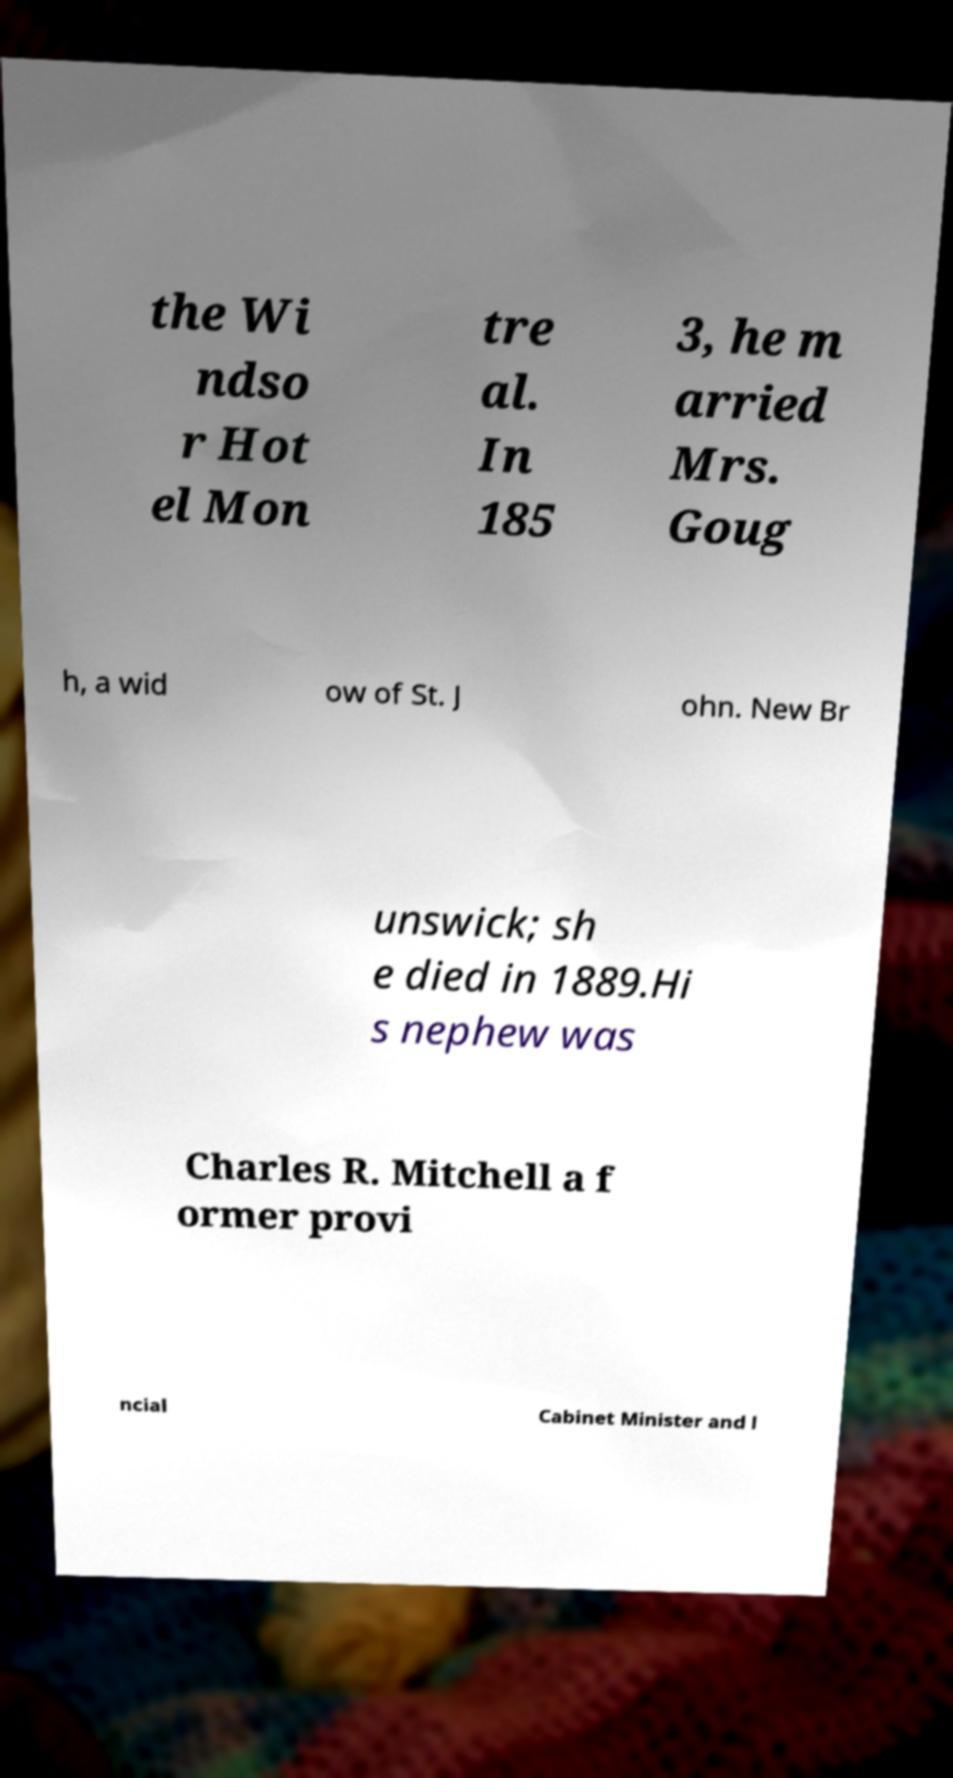Can you accurately transcribe the text from the provided image for me? the Wi ndso r Hot el Mon tre al. In 185 3, he m arried Mrs. Goug h, a wid ow of St. J ohn. New Br unswick; sh e died in 1889.Hi s nephew was Charles R. Mitchell a f ormer provi ncial Cabinet Minister and l 